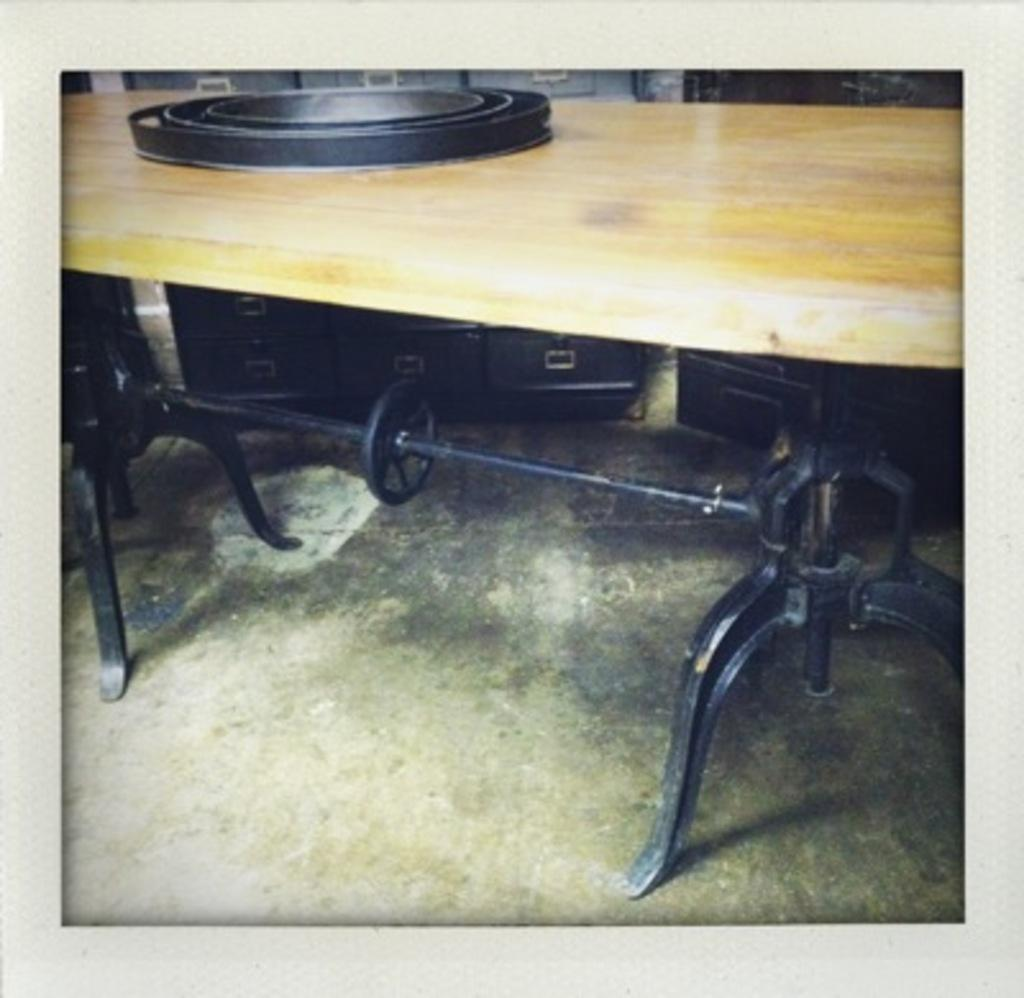What is the color of the object on the table? The object on the table is black. What is the color of the object on the floor? The object on the floor is black. Can you describe any objects visible in the background of the image? Unfortunately, the provided facts do not give any information about the objects in the background. Is the black object on the table attacking the black object on the floor? There is no indication of any attack or interaction between the objects in the image. 